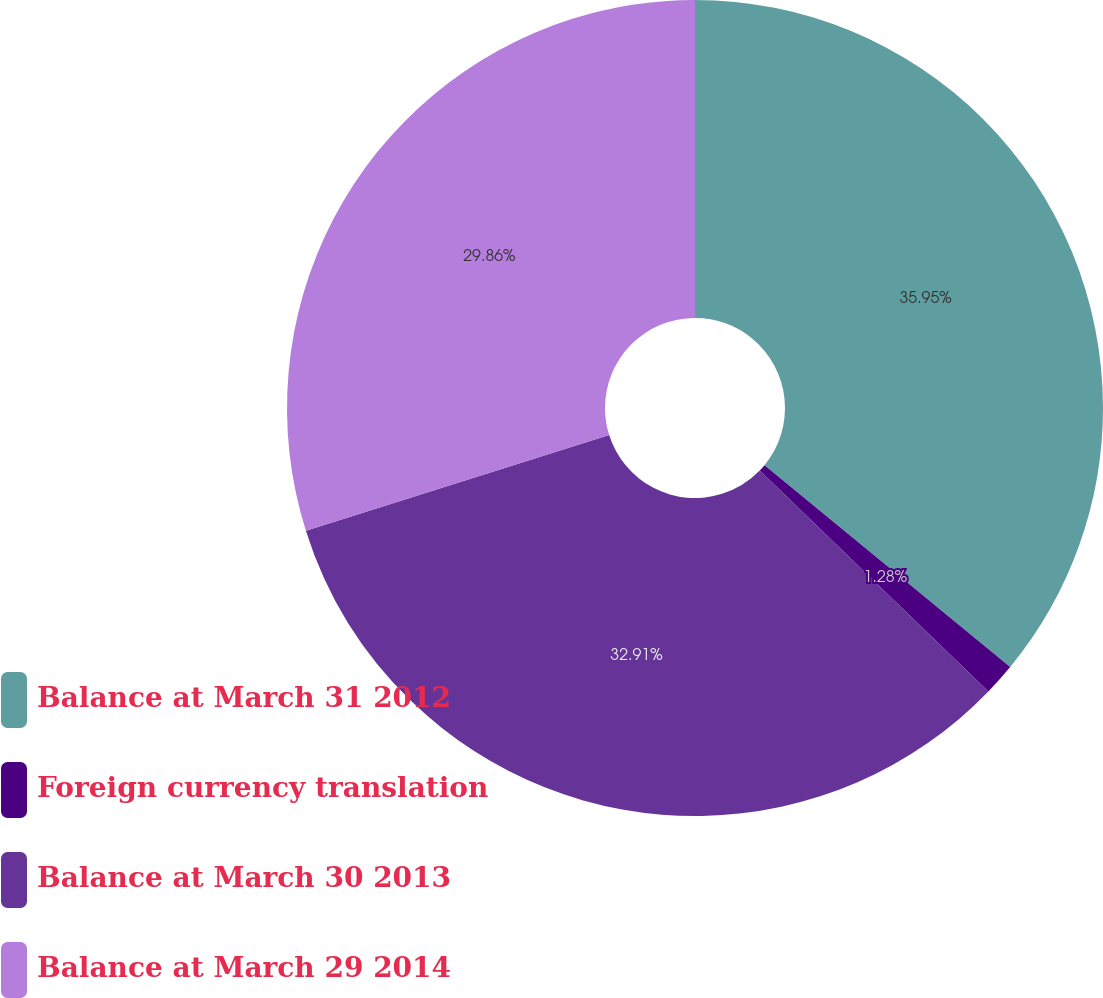<chart> <loc_0><loc_0><loc_500><loc_500><pie_chart><fcel>Balance at March 31 2012<fcel>Foreign currency translation<fcel>Balance at March 30 2013<fcel>Balance at March 29 2014<nl><fcel>35.95%<fcel>1.28%<fcel>32.91%<fcel>29.86%<nl></chart> 